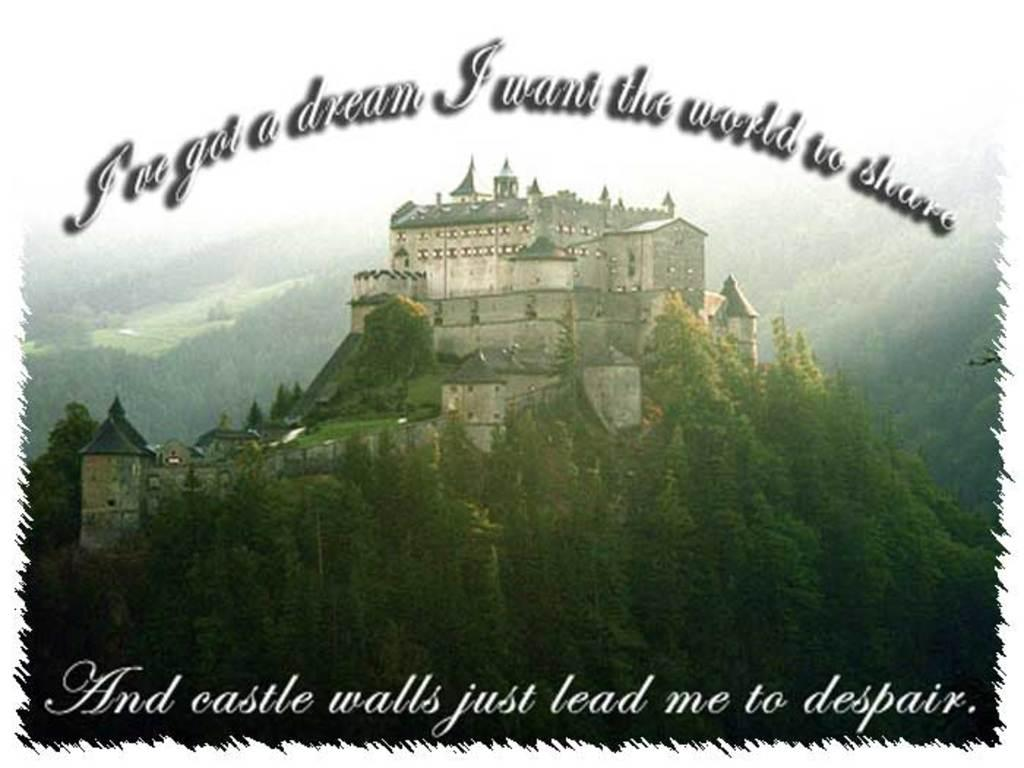What type of structure is present in the image? There is a castle in the image. What type of natural environment is visible in the image? There are trees in the image. What is written at the top of the image? There is text at the top of the image. What is written at the bottom of the image? There is text at the bottom of the image. What type of instrument can be seen being played by the eyes in the image? There are no instruments or eyes present in the image. What type of basket is visible in the image? There is no basket present in the image. 